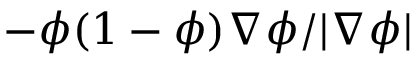Convert formula to latex. <formula><loc_0><loc_0><loc_500><loc_500>- \phi ( 1 - \phi ) \nabla \phi / | \nabla \phi |</formula> 